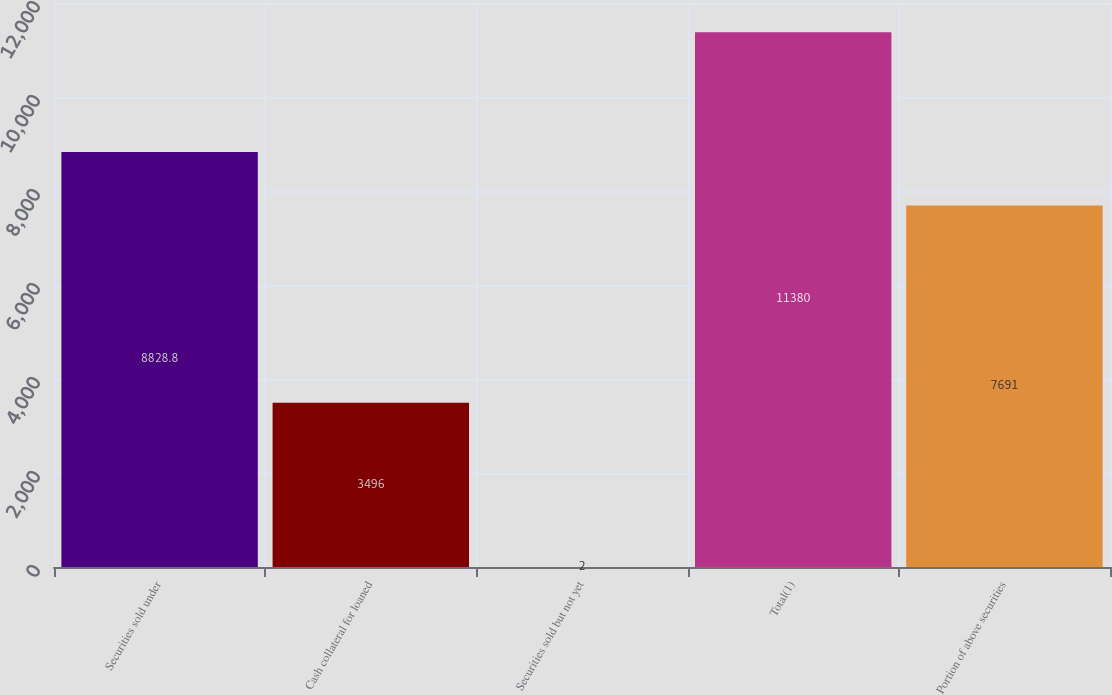Convert chart. <chart><loc_0><loc_0><loc_500><loc_500><bar_chart><fcel>Securities sold under<fcel>Cash collateral for loaned<fcel>Securities sold but not yet<fcel>Total(1)<fcel>Portion of above securities<nl><fcel>8828.8<fcel>3496<fcel>2<fcel>11380<fcel>7691<nl></chart> 